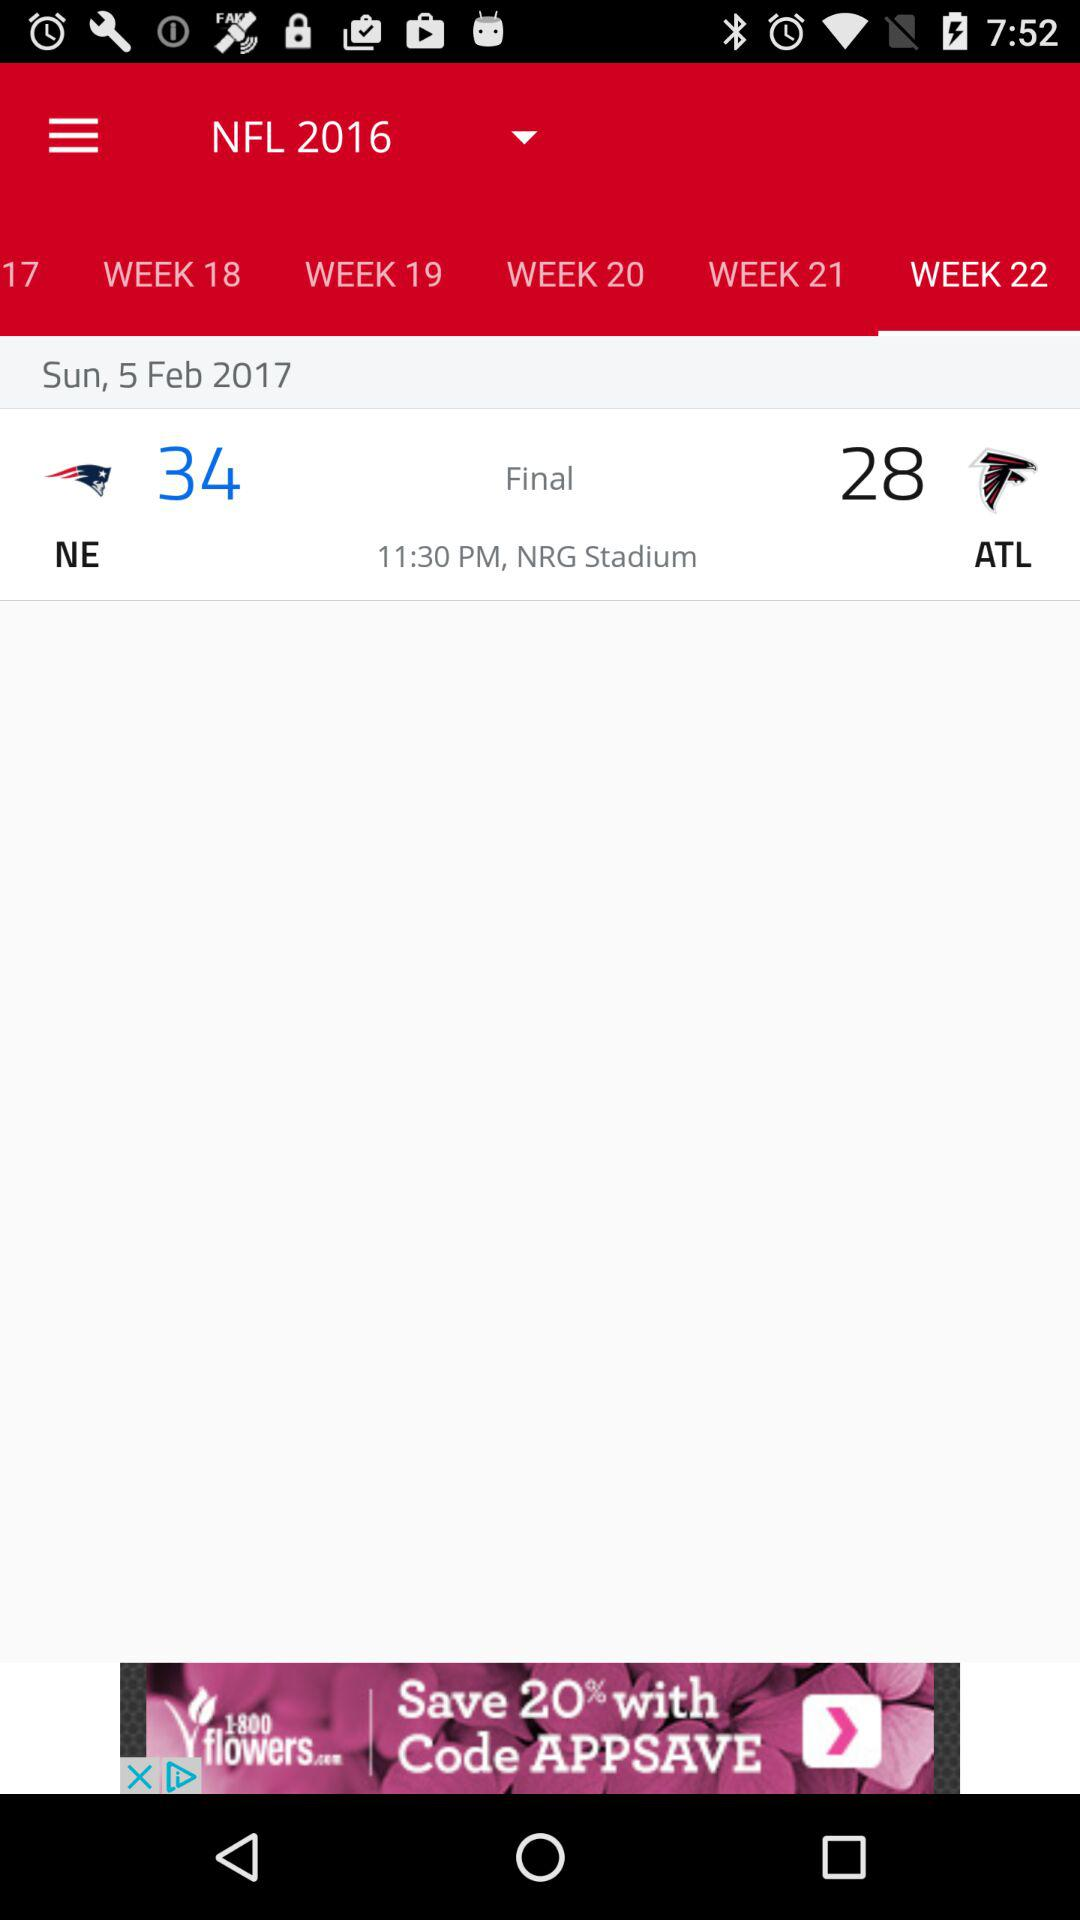What is the time of the match? The time of the match is 11:30 p.m. 